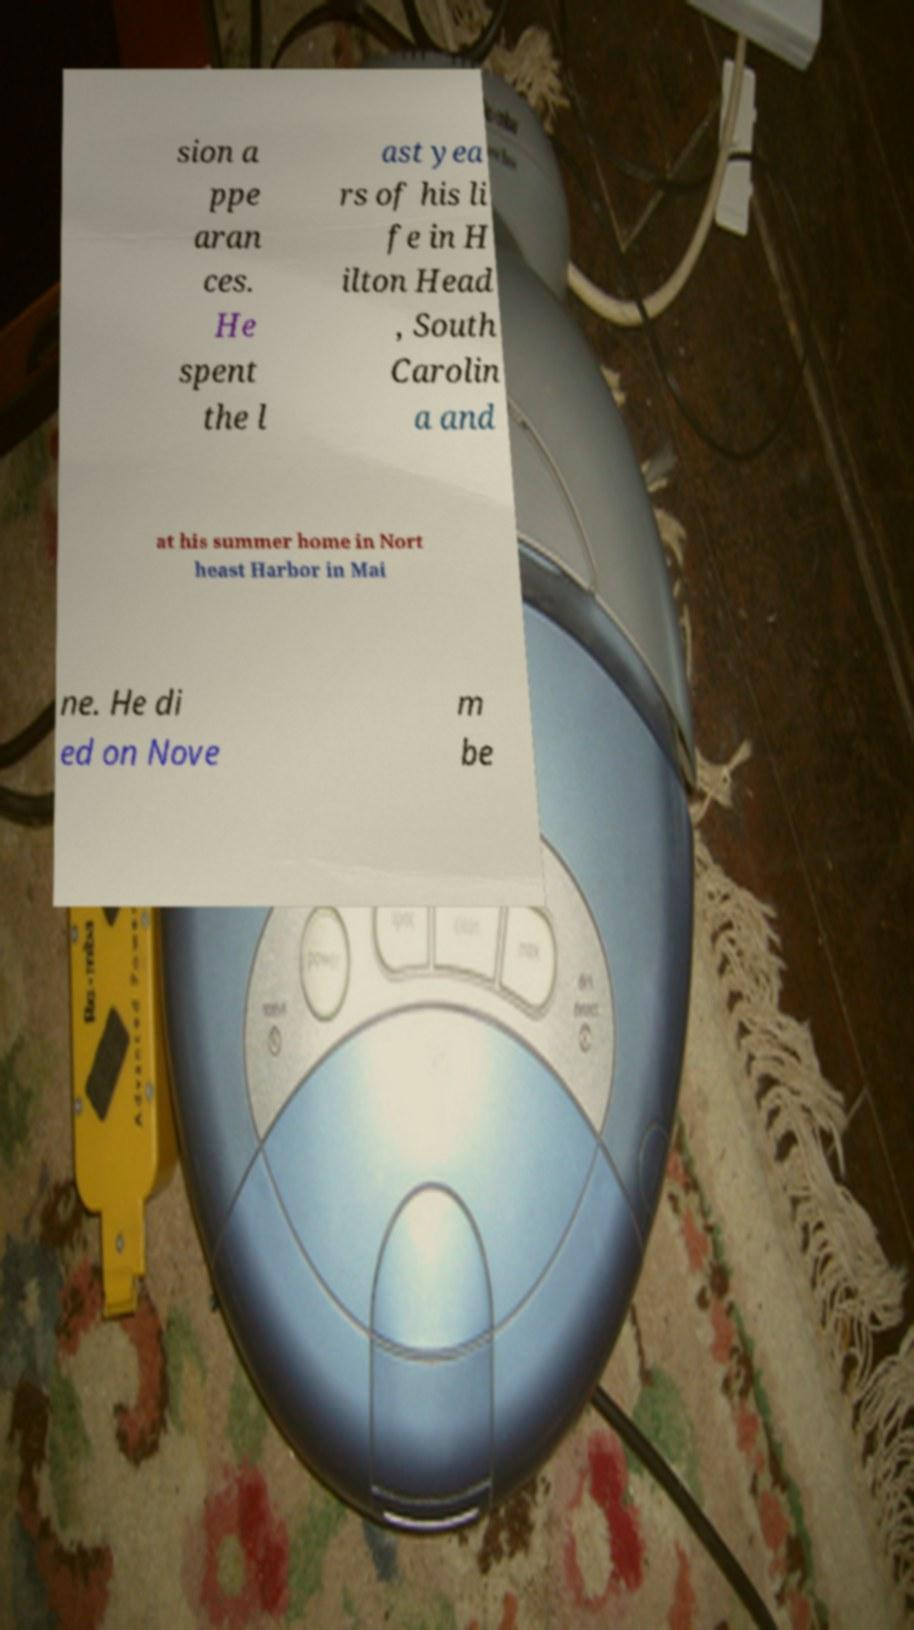What messages or text are displayed in this image? I need them in a readable, typed format. sion a ppe aran ces. He spent the l ast yea rs of his li fe in H ilton Head , South Carolin a and at his summer home in Nort heast Harbor in Mai ne. He di ed on Nove m be 